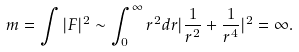<formula> <loc_0><loc_0><loc_500><loc_500>m = \int | F | ^ { 2 } \sim \int _ { 0 } ^ { \infty } r ^ { 2 } d r | \frac { 1 } { r ^ { 2 } } + \frac { 1 } { r ^ { 4 } } | ^ { 2 } = \infty .</formula> 